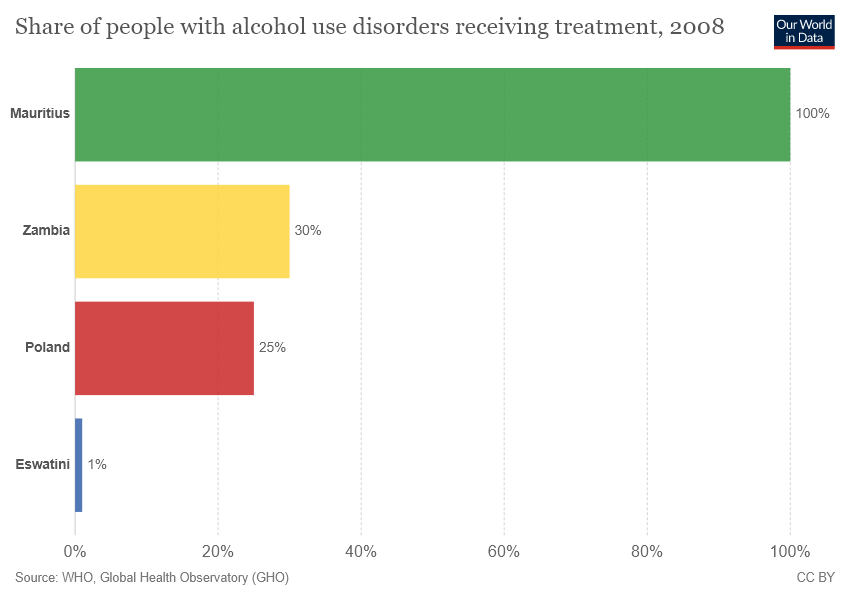Draw attention to some important aspects in this diagram. A yellow bar indicates that the data displayed belongs to Zambia. The average between Zambia and Poland is 27.5. 